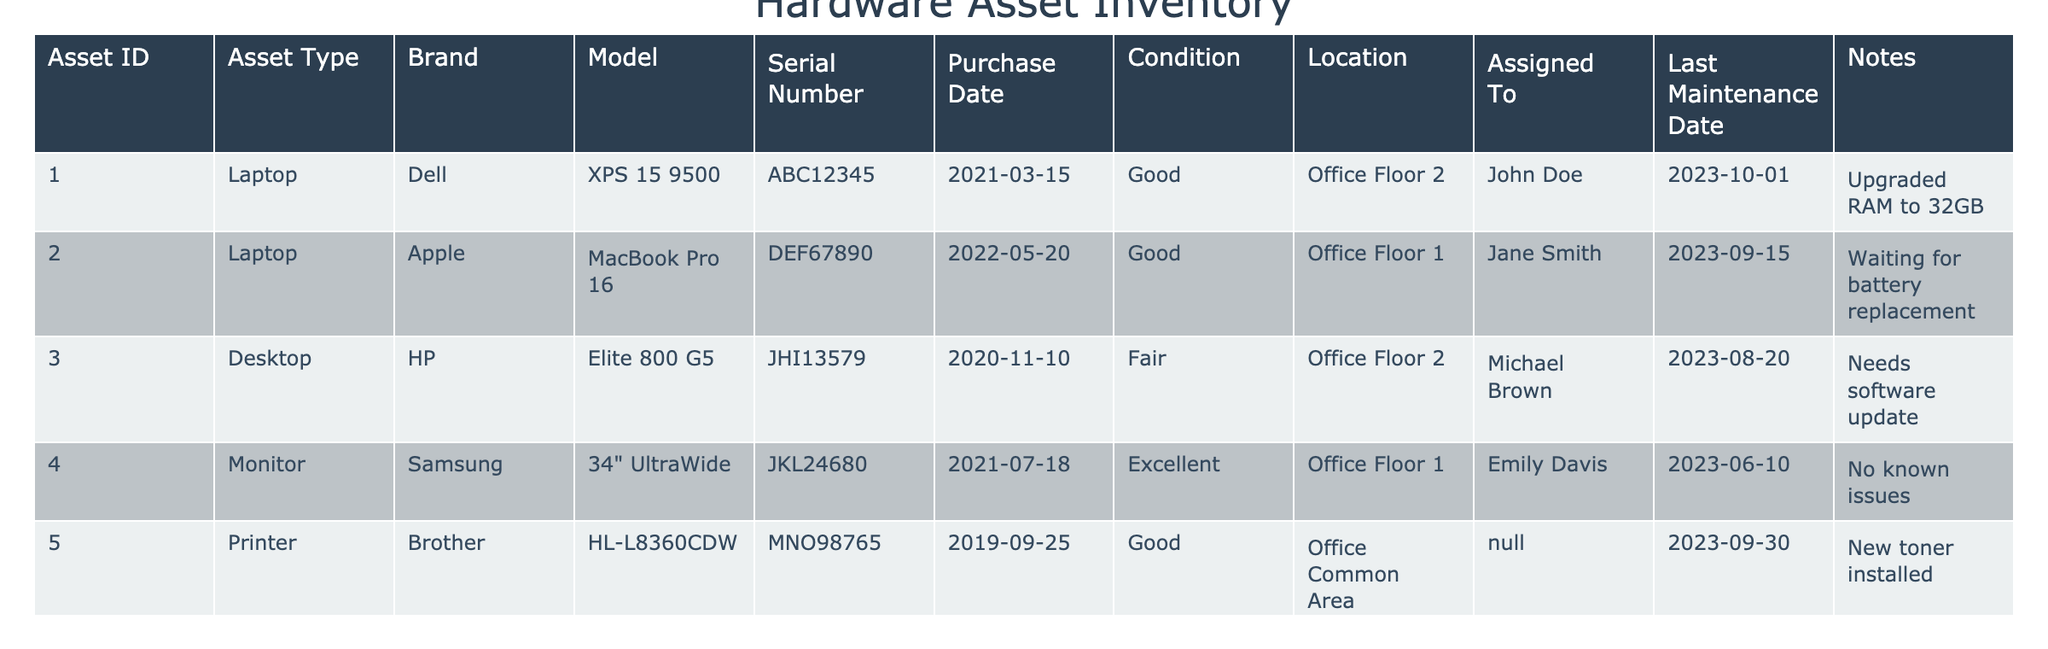What is the asset type of the item assigned to Michael Brown? The table shows that the item assigned to Michael Brown has the Asset ID 003, which is a Desktop according to the "Asset Type" column.
Answer: Desktop How many laptops are noted to have a good condition? From the table, there are two laptops listed with a "Good" condition: the Dell XPS 15 9500 and the Apple MacBook Pro 16, corresponding to Asset IDs 001 and 002. Therefore, the count is 2.
Answer: 2 Which asset was purchased most recently? Reviewing the "Purchase Date" column, the asset with the latest purchase date is the Zebra ET5X tablet with the purchase date of January 5, 2023, thus indicating that it is the most recent asset.
Answer: Tablet, Zebra ET5X Is there any asset that requires immediate maintenance? The item assigned to Jane Smith (the Apple MacBook Pro 16) is noted to be "Waiting for battery replacement", indicating that it requires immediate maintenance, thus the answer is yes based on this note.
Answer: Yes Which asset has the longest time since maintenance, and how many days has it been? The last maintenance date for the desktop assigned to Michael Brown is August 20, 2023. Calculating the difference from today (October 1, 2023) gives us 42 days since maintenance. No other asset's last maintenance exceeds this span between August 20 and October 1.
Answer: Desktop, 42 days Are there any monitors listed in excellent condition? Checking the "Condition" column for monitors, we can see that the Samsung 34" UltraWide is classified as "Excellent," which confirms that there is at least one monitor in excellent condition.
Answer: Yes What is the average purchase year of the assets listed in the table? The purchase dates of the assets show years 2019, 2020, 2021, and 2022. Summing those years (2019 + 2020 + 2021 + 2022) gives 8082, and dividing by 6 assets yields an average of approximately 2020.33, so considering the years only, the average purchase year is 2021 when rounded down.
Answer: 2021 Which asset is the only tablet listed, and what is its condition? From the table, there is one tablet listed which is the Zebra ET5X, and it is categorized as "New" in the "Condition" column without any prior wear or use mentioned.
Answer: Tablet, New How many assets are currently assigned to individuals? From the table, there are six assets assigned to individual users (John Doe, Jane Smith, Michael Brown, Emily Davis, and Alice Johnson). Only the printer and router are not assigned, making the total assigned assets equal to 5.
Answer: 5 